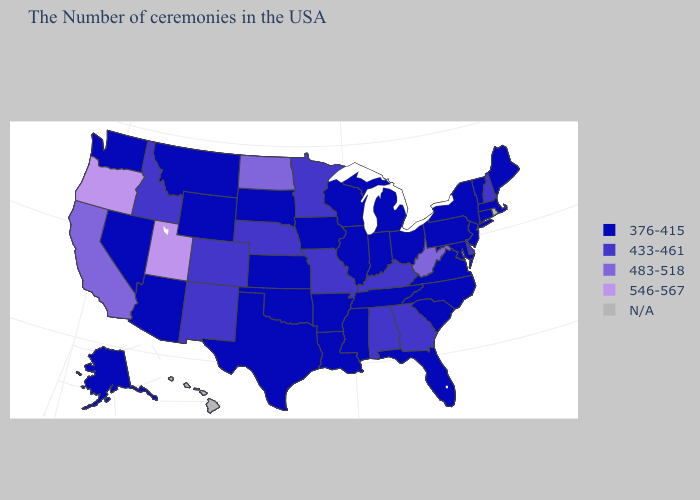What is the value of Louisiana?
Quick response, please. 376-415. Name the states that have a value in the range 376-415?
Quick response, please. Maine, Massachusetts, Vermont, Connecticut, New York, New Jersey, Maryland, Pennsylvania, Virginia, North Carolina, South Carolina, Ohio, Florida, Michigan, Indiana, Tennessee, Wisconsin, Illinois, Mississippi, Louisiana, Arkansas, Iowa, Kansas, Oklahoma, Texas, South Dakota, Wyoming, Montana, Arizona, Nevada, Washington, Alaska. Does the map have missing data?
Concise answer only. Yes. Among the states that border West Virginia , does Kentucky have the highest value?
Write a very short answer. Yes. What is the value of Colorado?
Quick response, please. 433-461. What is the value of Louisiana?
Quick response, please. 376-415. Among the states that border Minnesota , does South Dakota have the highest value?
Short answer required. No. What is the lowest value in states that border New Jersey?
Quick response, please. 376-415. What is the value of Illinois?
Be succinct. 376-415. Name the states that have a value in the range 433-461?
Answer briefly. New Hampshire, Delaware, Georgia, Kentucky, Alabama, Missouri, Minnesota, Nebraska, Colorado, New Mexico, Idaho. What is the value of Oklahoma?
Concise answer only. 376-415. What is the highest value in states that border Nebraska?
Keep it brief. 433-461. What is the highest value in the MidWest ?
Concise answer only. 483-518. 